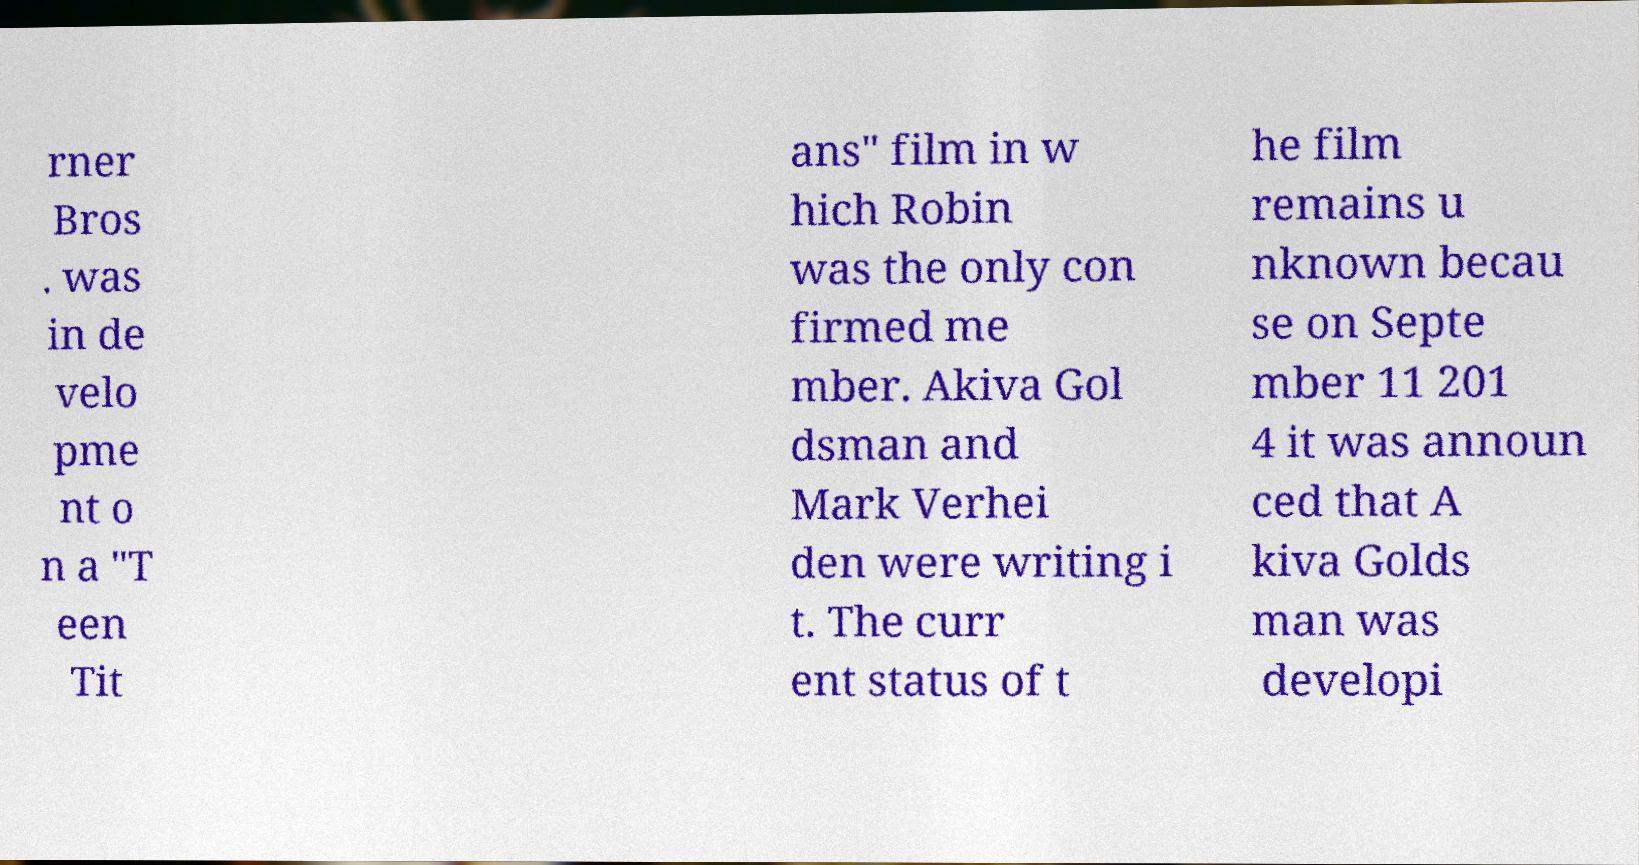I need the written content from this picture converted into text. Can you do that? rner Bros . was in de velo pme nt o n a "T een Tit ans" film in w hich Robin was the only con firmed me mber. Akiva Gol dsman and Mark Verhei den were writing i t. The curr ent status of t he film remains u nknown becau se on Septe mber 11 201 4 it was announ ced that A kiva Golds man was developi 